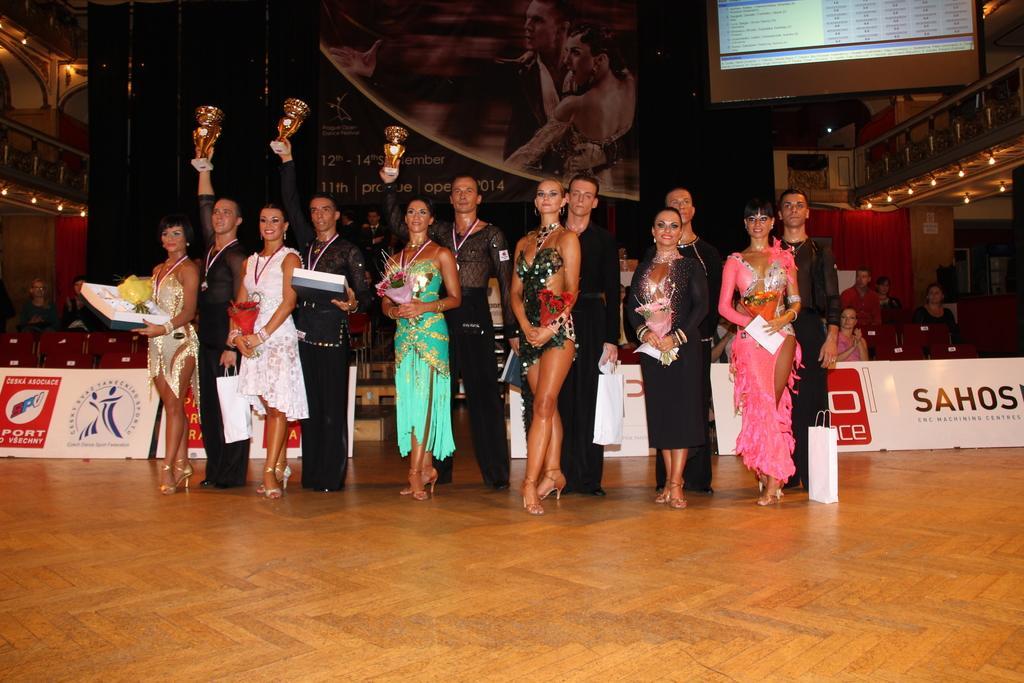Could you give a brief overview of what you see in this image? As we can see in the image there are few people standing in the front, banners, screen, lights and chairs. 